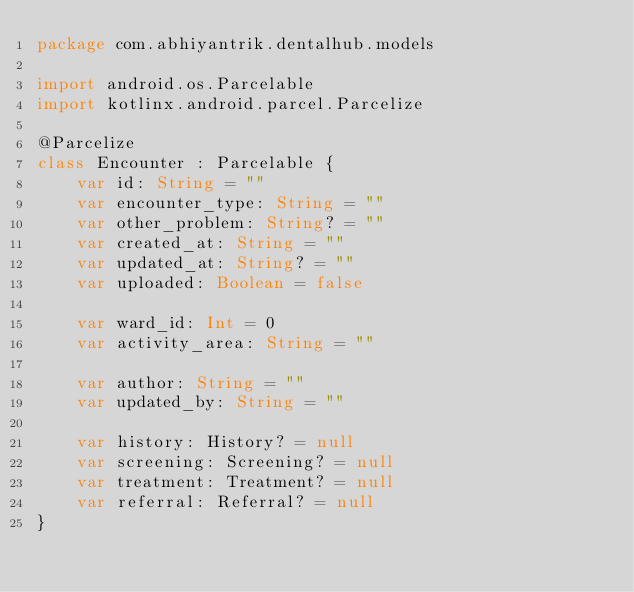<code> <loc_0><loc_0><loc_500><loc_500><_Kotlin_>package com.abhiyantrik.dentalhub.models

import android.os.Parcelable
import kotlinx.android.parcel.Parcelize

@Parcelize
class Encounter : Parcelable {
    var id: String = ""
    var encounter_type: String = ""
    var other_problem: String? = ""
    var created_at: String = ""
    var updated_at: String? = ""
    var uploaded: Boolean = false

    var ward_id: Int = 0
    var activity_area: String = ""

    var author: String = ""
    var updated_by: String = ""

    var history: History? = null
    var screening: Screening? = null
    var treatment: Treatment? = null
    var referral: Referral? = null
}
</code> 